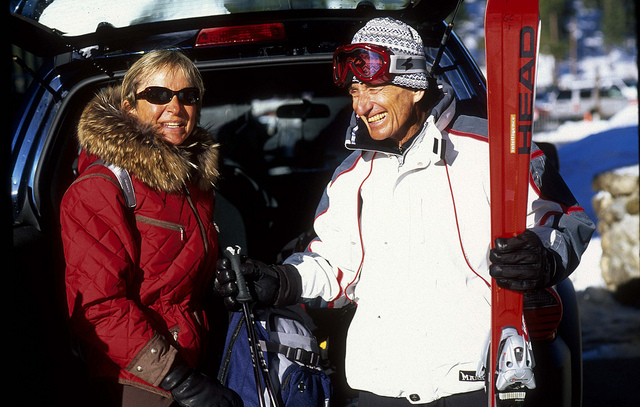Identify the text contained in this image. HEAD 